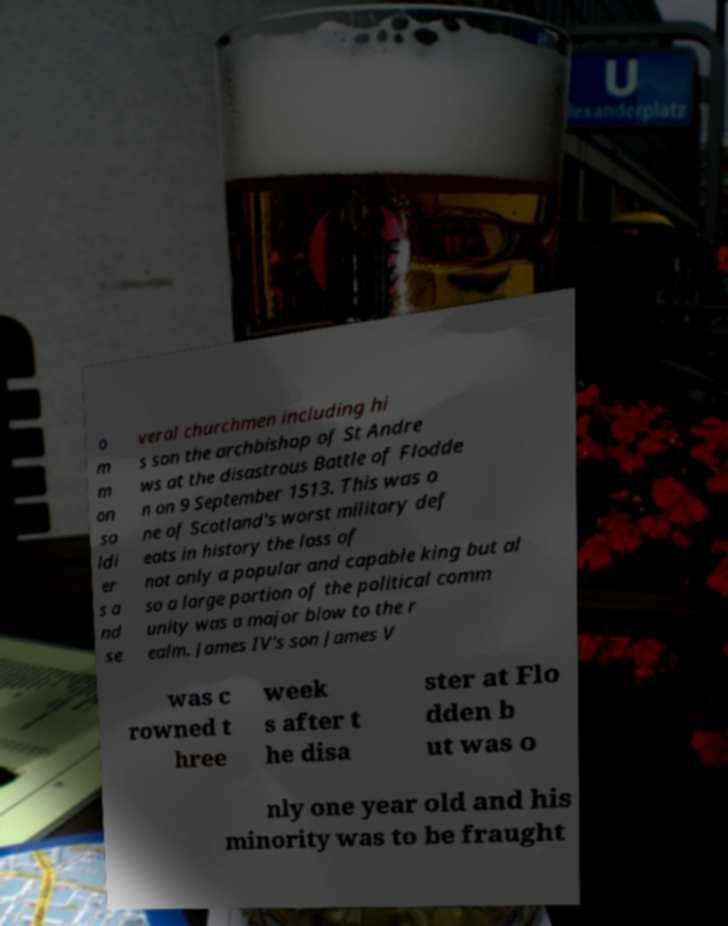There's text embedded in this image that I need extracted. Can you transcribe it verbatim? o m m on so ldi er s a nd se veral churchmen including hi s son the archbishop of St Andre ws at the disastrous Battle of Flodde n on 9 September 1513. This was o ne of Scotland's worst military def eats in history the loss of not only a popular and capable king but al so a large portion of the political comm unity was a major blow to the r ealm. James IV's son James V was c rowned t hree week s after t he disa ster at Flo dden b ut was o nly one year old and his minority was to be fraught 